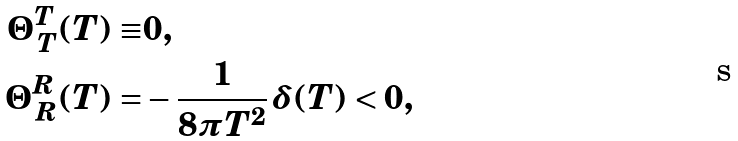Convert formula to latex. <formula><loc_0><loc_0><loc_500><loc_500>\Theta ^ { T } _ { \, T } ( T ) \equiv & 0 , \\ \Theta ^ { R } _ { \, R } ( T ) = & - \frac { 1 } { 8 \pi T ^ { 2 } } \, \delta ( T ) < 0 ,</formula> 